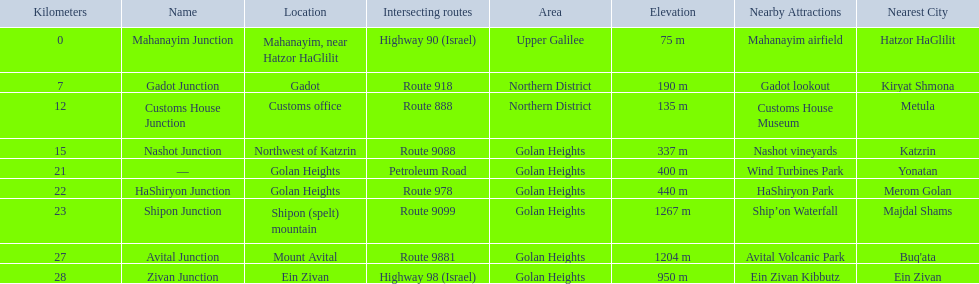Which intersecting routes are route 918 Route 918. What is the name? Gadot Junction. 